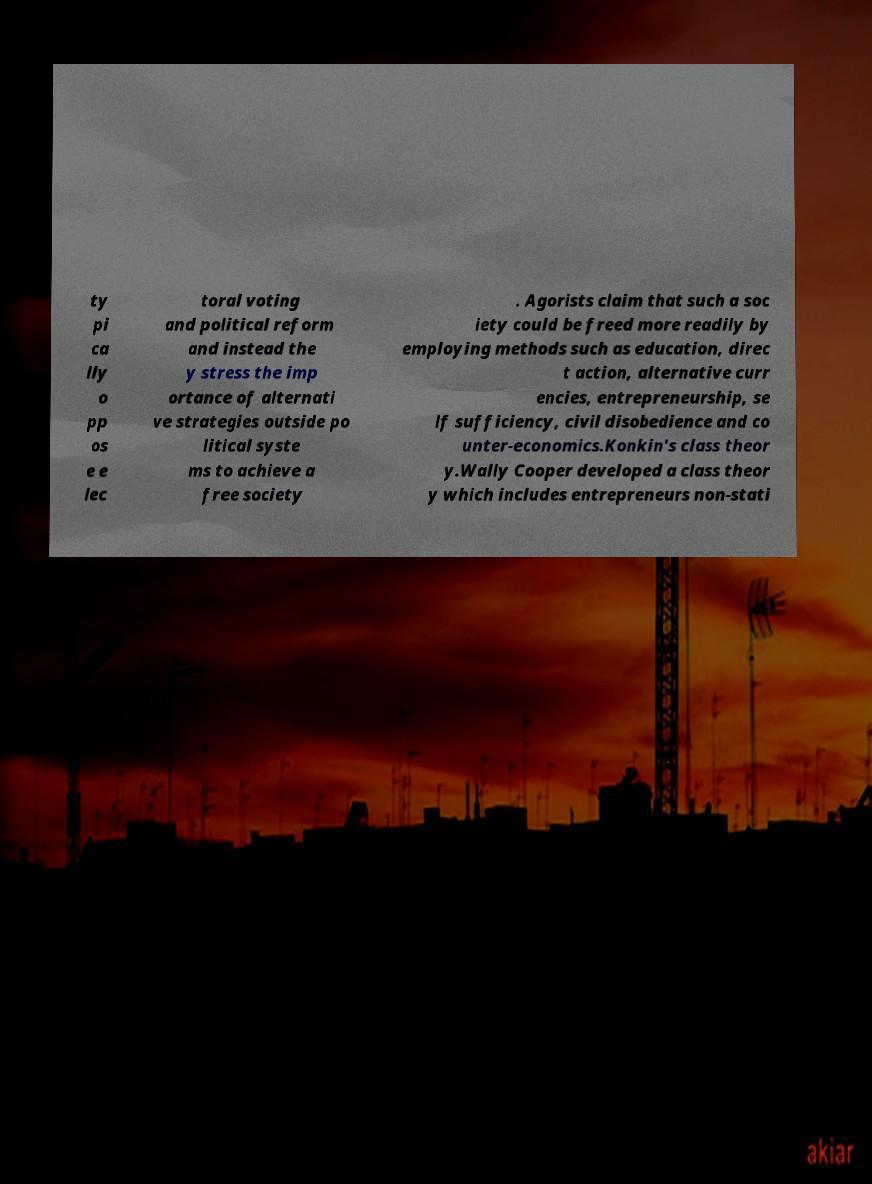For documentation purposes, I need the text within this image transcribed. Could you provide that? ty pi ca lly o pp os e e lec toral voting and political reform and instead the y stress the imp ortance of alternati ve strategies outside po litical syste ms to achieve a free society . Agorists claim that such a soc iety could be freed more readily by employing methods such as education, direc t action, alternative curr encies, entrepreneurship, se lf sufficiency, civil disobedience and co unter-economics.Konkin's class theor y.Wally Cooper developed a class theor y which includes entrepreneurs non-stati 